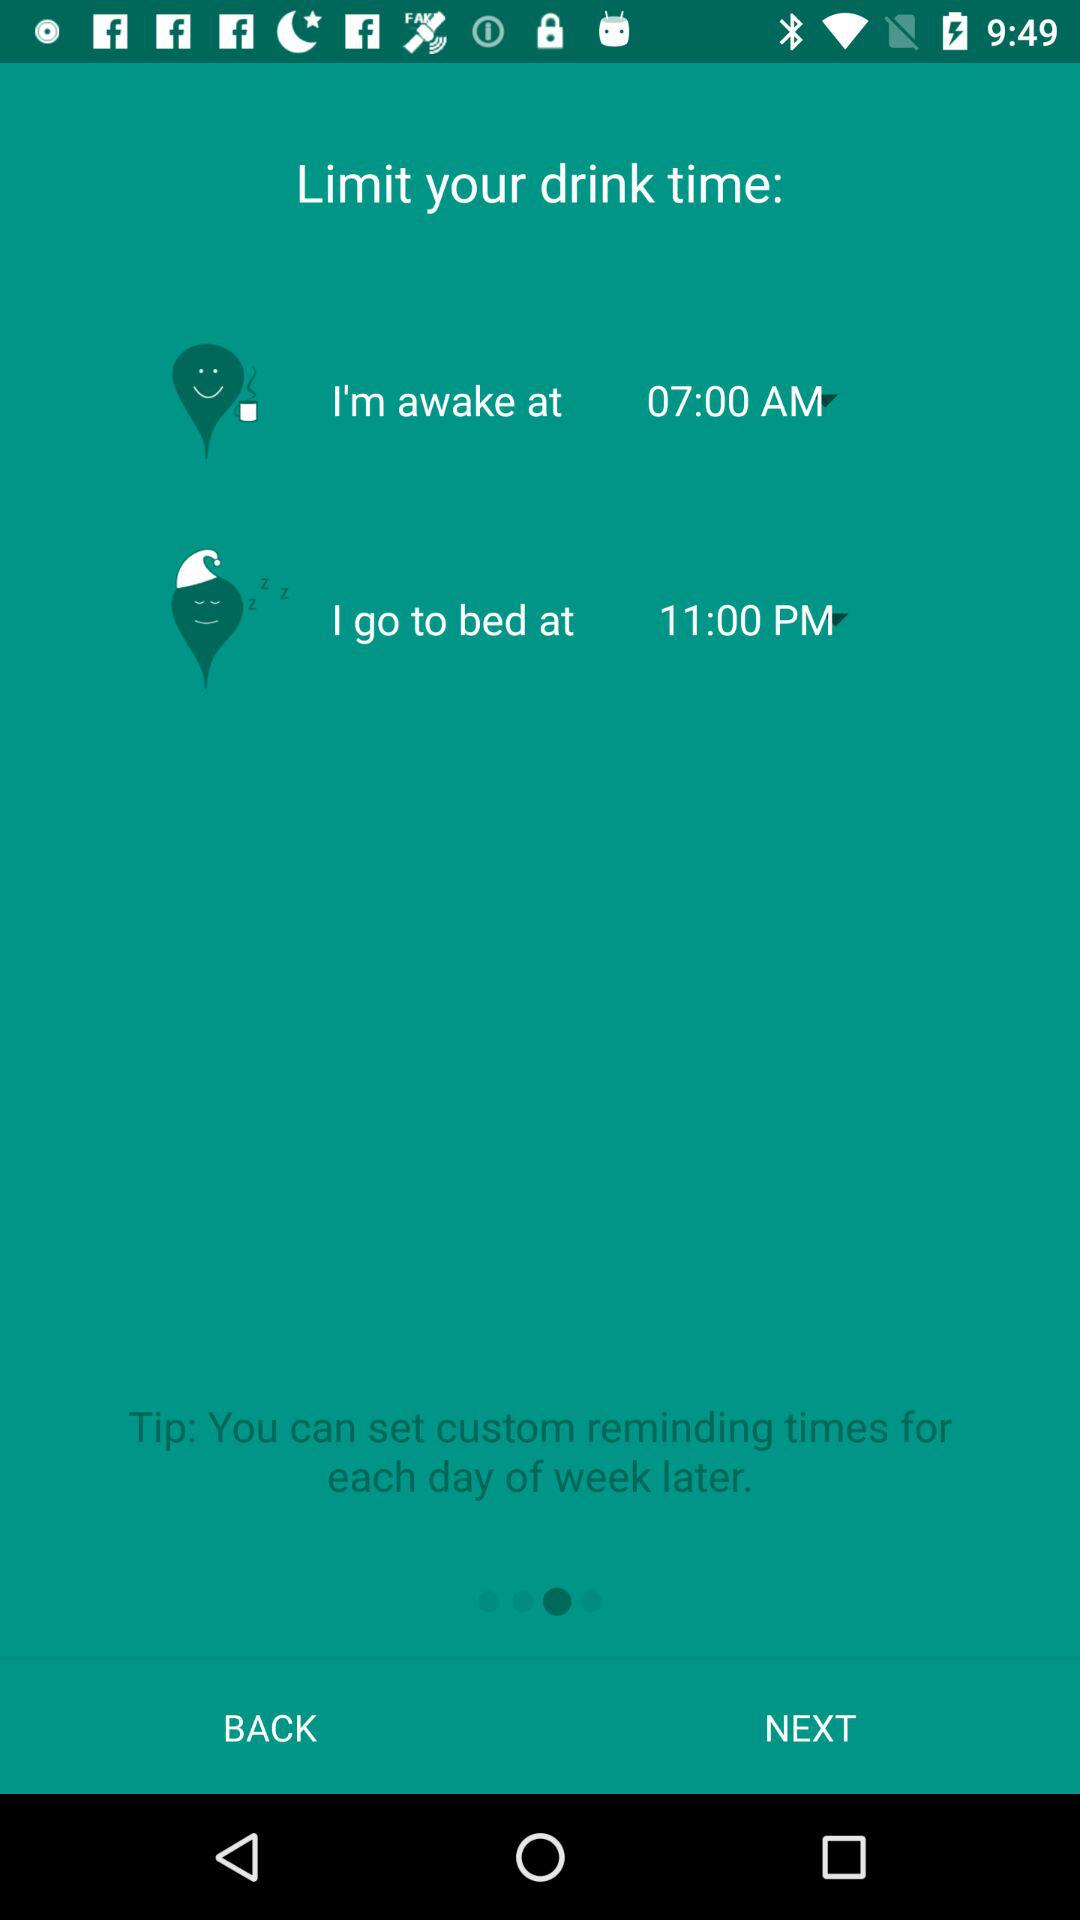How much can the user drink before bed?
When the provided information is insufficient, respond with <no answer>. <no answer> 